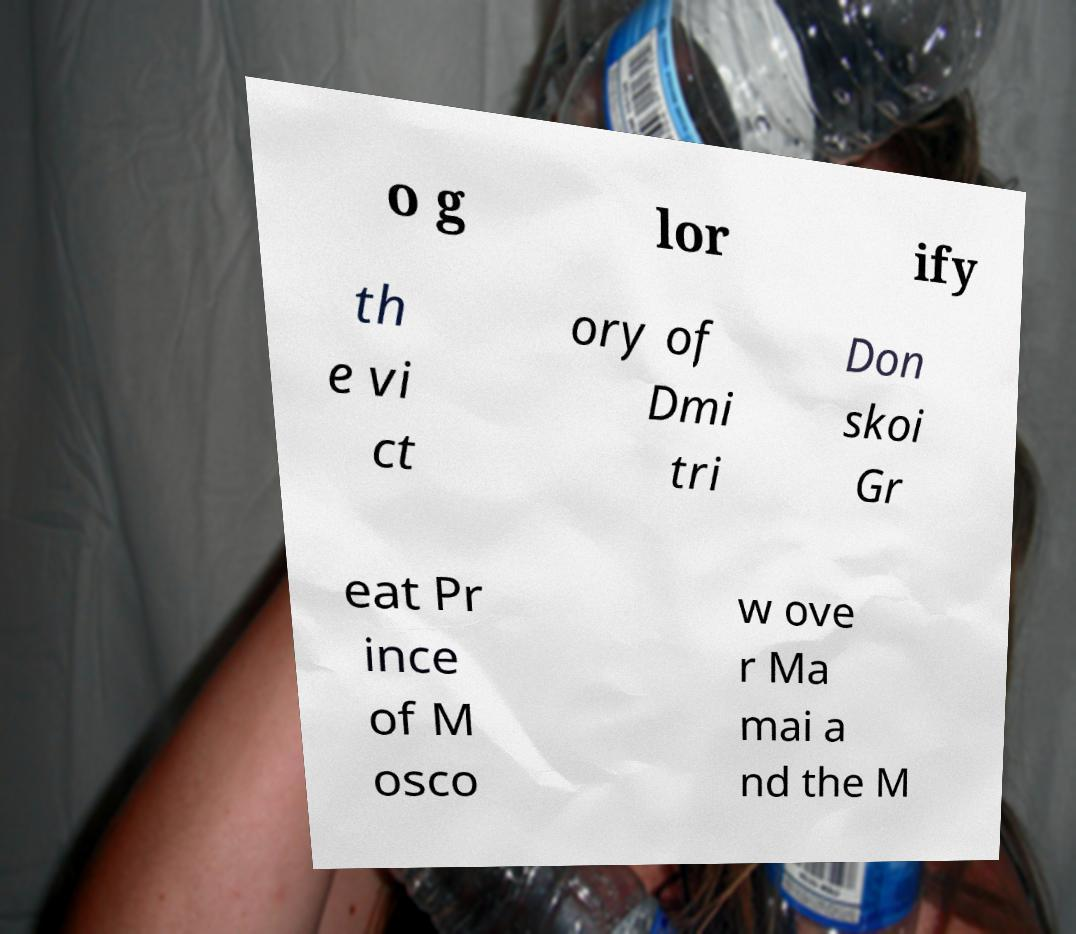What messages or text are displayed in this image? I need them in a readable, typed format. o g lor ify th e vi ct ory of Dmi tri Don skoi Gr eat Pr ince of M osco w ove r Ma mai a nd the M 